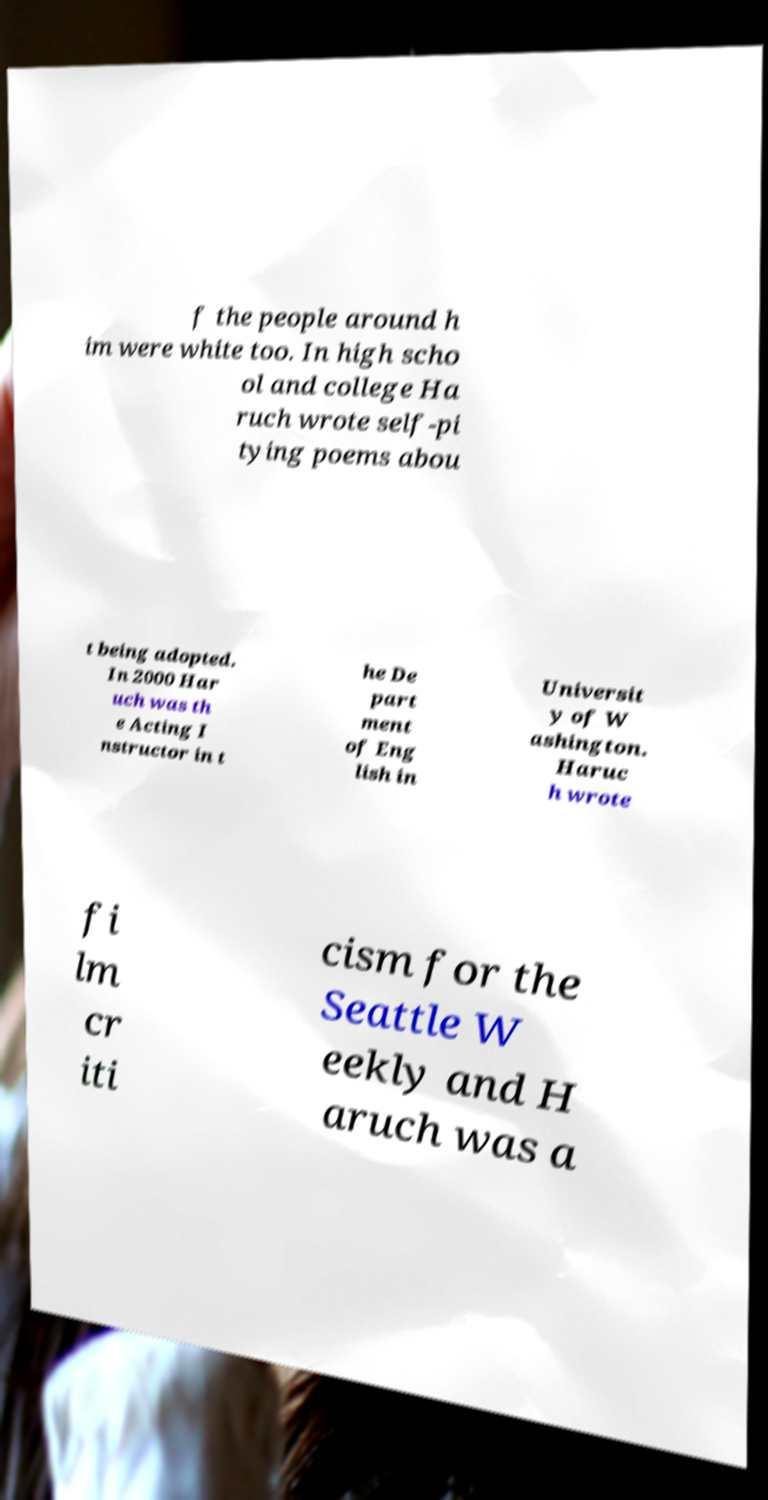There's text embedded in this image that I need extracted. Can you transcribe it verbatim? f the people around h im were white too. In high scho ol and college Ha ruch wrote self-pi tying poems abou t being adopted. In 2000 Har uch was th e Acting I nstructor in t he De part ment of Eng lish in Universit y of W ashington. Haruc h wrote fi lm cr iti cism for the Seattle W eekly and H aruch was a 